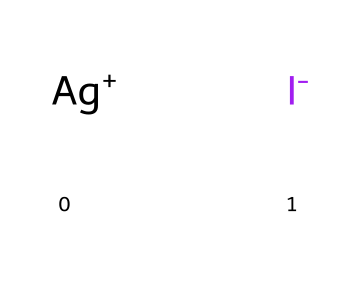What is the oxidation state of silver in this compound? In the coordination complex, silver is represented as [Ag+], indicating that it is in a +1 oxidation state. Therefore, the charge of silver shows its oxidation state directly.
Answer: +1 How many total atoms are present in this compound? The chemical consists of one silver atom (Ag) and one iodine atom (I), leading to a total of two atoms in the complex.
Answer: 2 What type of chemical bond is present between silver and iodine? The bond between the positively charged silver cation and the negatively charged iodide anion is an ionic bond, as one atom donates an electron, resulting in attraction between the opposite charges.
Answer: ionic What is the coordination number of silver in this complex? In the given structure, silver coordinates with a single iodide ion, indicating a coordination number of 1.
Answer: 1 Is this complex soluble in water? Silver iodide is known to be poorly soluble in water due to strong ionic interactions. Therefore, it has limited solubility in aqueous solutions.
Answer: poorly soluble What role does this compound play in weather modification experiments? Silver iodide is used as a cloud seeding agent because its crystalline structure can initiate ice crystal formation in supercooled cloud droplets, enhancing precipitation processes.
Answer: cloud seeding agent 